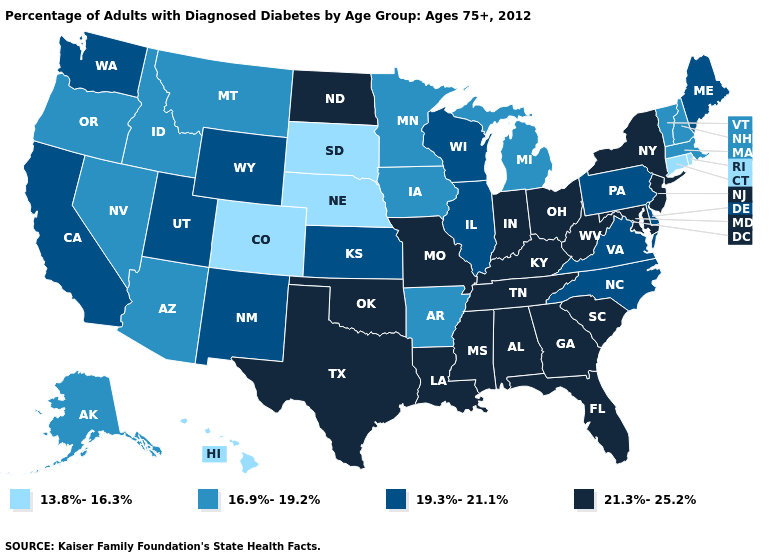Which states hav the highest value in the West?
Keep it brief. California, New Mexico, Utah, Washington, Wyoming. Does North Carolina have the highest value in the USA?
Keep it brief. No. What is the value of Indiana?
Concise answer only. 21.3%-25.2%. What is the value of Arkansas?
Answer briefly. 16.9%-19.2%. Among the states that border Michigan , does Wisconsin have the lowest value?
Concise answer only. Yes. What is the highest value in states that border Idaho?
Keep it brief. 19.3%-21.1%. Name the states that have a value in the range 19.3%-21.1%?
Quick response, please. California, Delaware, Illinois, Kansas, Maine, New Mexico, North Carolina, Pennsylvania, Utah, Virginia, Washington, Wisconsin, Wyoming. What is the value of Alabama?
Concise answer only. 21.3%-25.2%. Name the states that have a value in the range 13.8%-16.3%?
Be succinct. Colorado, Connecticut, Hawaii, Nebraska, Rhode Island, South Dakota. What is the value of Hawaii?
Be succinct. 13.8%-16.3%. Is the legend a continuous bar?
Quick response, please. No. Which states have the lowest value in the Northeast?
Short answer required. Connecticut, Rhode Island. Which states hav the highest value in the West?
Short answer required. California, New Mexico, Utah, Washington, Wyoming. What is the value of West Virginia?
Be succinct. 21.3%-25.2%. Does Pennsylvania have the lowest value in the Northeast?
Quick response, please. No. 